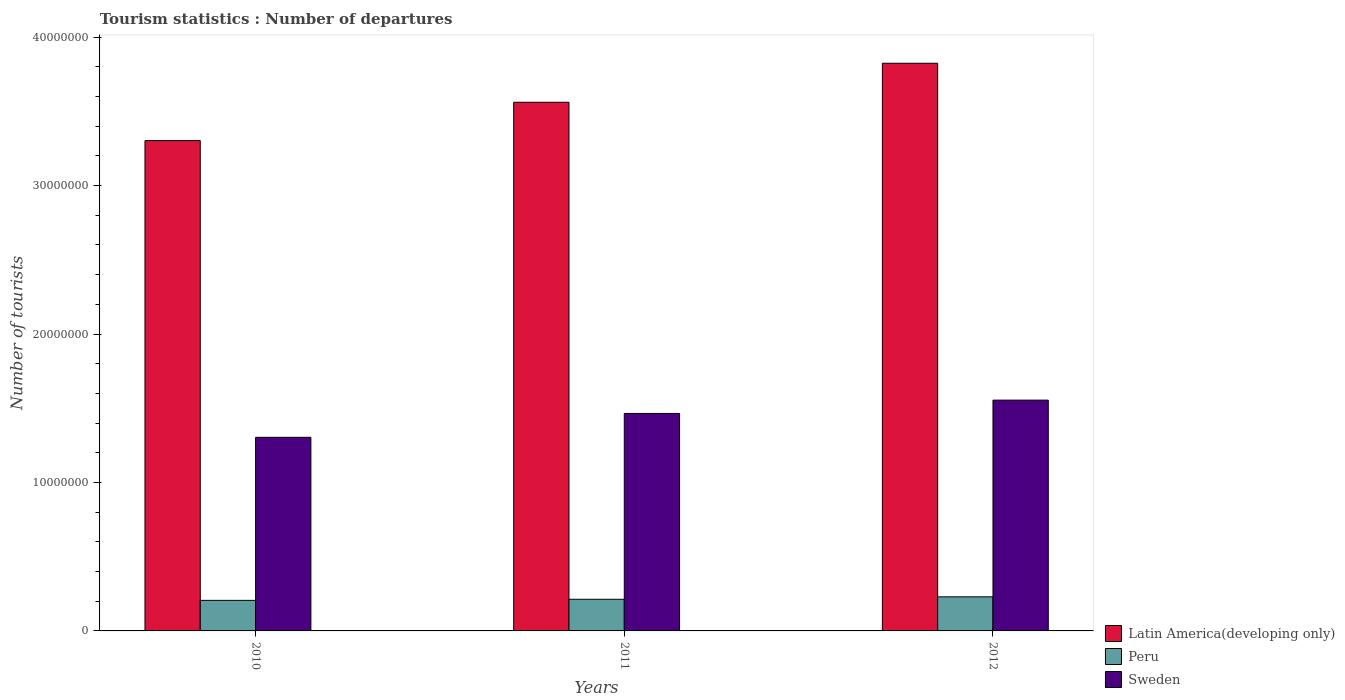How many groups of bars are there?
Keep it short and to the point. 3. Are the number of bars per tick equal to the number of legend labels?
Offer a terse response. Yes. Are the number of bars on each tick of the X-axis equal?
Keep it short and to the point. Yes. How many bars are there on the 3rd tick from the left?
Keep it short and to the point. 3. What is the label of the 1st group of bars from the left?
Your answer should be compact. 2010. In how many cases, is the number of bars for a given year not equal to the number of legend labels?
Ensure brevity in your answer.  0. What is the number of tourist departures in Latin America(developing only) in 2012?
Ensure brevity in your answer.  3.82e+07. Across all years, what is the maximum number of tourist departures in Sweden?
Provide a short and direct response. 1.55e+07. Across all years, what is the minimum number of tourist departures in Peru?
Offer a very short reply. 2.06e+06. What is the total number of tourist departures in Peru in the graph?
Make the answer very short. 6.49e+06. What is the difference between the number of tourist departures in Latin America(developing only) in 2011 and that in 2012?
Your response must be concise. -2.63e+06. What is the difference between the number of tourist departures in Sweden in 2010 and the number of tourist departures in Peru in 2012?
Keep it short and to the point. 1.07e+07. What is the average number of tourist departures in Sweden per year?
Your answer should be compact. 1.44e+07. In the year 2011, what is the difference between the number of tourist departures in Peru and number of tourist departures in Latin America(developing only)?
Provide a short and direct response. -3.35e+07. In how many years, is the number of tourist departures in Latin America(developing only) greater than 20000000?
Your answer should be compact. 3. What is the ratio of the number of tourist departures in Sweden in 2011 to that in 2012?
Your response must be concise. 0.94. Is the difference between the number of tourist departures in Peru in 2011 and 2012 greater than the difference between the number of tourist departures in Latin America(developing only) in 2011 and 2012?
Your answer should be compact. Yes. What is the difference between the highest and the second highest number of tourist departures in Sweden?
Provide a succinct answer. 8.97e+05. What is the difference between the highest and the lowest number of tourist departures in Latin America(developing only)?
Offer a terse response. 5.21e+06. Is the sum of the number of tourist departures in Sweden in 2010 and 2011 greater than the maximum number of tourist departures in Latin America(developing only) across all years?
Offer a terse response. No. What does the 1st bar from the left in 2010 represents?
Offer a very short reply. Latin America(developing only). How many years are there in the graph?
Your answer should be compact. 3. Are the values on the major ticks of Y-axis written in scientific E-notation?
Keep it short and to the point. No. Does the graph contain grids?
Keep it short and to the point. No. How many legend labels are there?
Offer a terse response. 3. How are the legend labels stacked?
Give a very brief answer. Vertical. What is the title of the graph?
Your response must be concise. Tourism statistics : Number of departures. What is the label or title of the Y-axis?
Ensure brevity in your answer.  Number of tourists. What is the Number of tourists of Latin America(developing only) in 2010?
Your answer should be very brief. 3.30e+07. What is the Number of tourists of Peru in 2010?
Your response must be concise. 2.06e+06. What is the Number of tourists of Sweden in 2010?
Your answer should be very brief. 1.30e+07. What is the Number of tourists in Latin America(developing only) in 2011?
Your response must be concise. 3.56e+07. What is the Number of tourists in Peru in 2011?
Keep it short and to the point. 2.13e+06. What is the Number of tourists of Sweden in 2011?
Offer a very short reply. 1.47e+07. What is the Number of tourists in Latin America(developing only) in 2012?
Your response must be concise. 3.82e+07. What is the Number of tourists in Peru in 2012?
Offer a very short reply. 2.30e+06. What is the Number of tourists in Sweden in 2012?
Provide a short and direct response. 1.55e+07. Across all years, what is the maximum Number of tourists in Latin America(developing only)?
Give a very brief answer. 3.82e+07. Across all years, what is the maximum Number of tourists in Peru?
Make the answer very short. 2.30e+06. Across all years, what is the maximum Number of tourists of Sweden?
Ensure brevity in your answer.  1.55e+07. Across all years, what is the minimum Number of tourists of Latin America(developing only)?
Your answer should be compact. 3.30e+07. Across all years, what is the minimum Number of tourists in Peru?
Give a very brief answer. 2.06e+06. Across all years, what is the minimum Number of tourists in Sweden?
Offer a terse response. 1.30e+07. What is the total Number of tourists of Latin America(developing only) in the graph?
Give a very brief answer. 1.07e+08. What is the total Number of tourists of Peru in the graph?
Ensure brevity in your answer.  6.49e+06. What is the total Number of tourists in Sweden in the graph?
Your answer should be very brief. 4.32e+07. What is the difference between the Number of tourists of Latin America(developing only) in 2010 and that in 2011?
Your answer should be very brief. -2.58e+06. What is the difference between the Number of tourists in Peru in 2010 and that in 2011?
Your answer should be very brief. -7.40e+04. What is the difference between the Number of tourists of Sweden in 2010 and that in 2011?
Provide a short and direct response. -1.61e+06. What is the difference between the Number of tourists of Latin America(developing only) in 2010 and that in 2012?
Give a very brief answer. -5.21e+06. What is the difference between the Number of tourists of Peru in 2010 and that in 2012?
Provide a short and direct response. -2.38e+05. What is the difference between the Number of tourists in Sweden in 2010 and that in 2012?
Offer a very short reply. -2.51e+06. What is the difference between the Number of tourists in Latin America(developing only) in 2011 and that in 2012?
Provide a succinct answer. -2.63e+06. What is the difference between the Number of tourists in Peru in 2011 and that in 2012?
Give a very brief answer. -1.64e+05. What is the difference between the Number of tourists of Sweden in 2011 and that in 2012?
Your answer should be very brief. -8.97e+05. What is the difference between the Number of tourists of Latin America(developing only) in 2010 and the Number of tourists of Peru in 2011?
Give a very brief answer. 3.09e+07. What is the difference between the Number of tourists of Latin America(developing only) in 2010 and the Number of tourists of Sweden in 2011?
Your answer should be very brief. 1.84e+07. What is the difference between the Number of tourists in Peru in 2010 and the Number of tourists in Sweden in 2011?
Your response must be concise. -1.26e+07. What is the difference between the Number of tourists in Latin America(developing only) in 2010 and the Number of tourists in Peru in 2012?
Give a very brief answer. 3.07e+07. What is the difference between the Number of tourists in Latin America(developing only) in 2010 and the Number of tourists in Sweden in 2012?
Provide a succinct answer. 1.75e+07. What is the difference between the Number of tourists of Peru in 2010 and the Number of tourists of Sweden in 2012?
Provide a succinct answer. -1.35e+07. What is the difference between the Number of tourists of Latin America(developing only) in 2011 and the Number of tourists of Peru in 2012?
Ensure brevity in your answer.  3.33e+07. What is the difference between the Number of tourists of Latin America(developing only) in 2011 and the Number of tourists of Sweden in 2012?
Ensure brevity in your answer.  2.01e+07. What is the difference between the Number of tourists in Peru in 2011 and the Number of tourists in Sweden in 2012?
Keep it short and to the point. -1.34e+07. What is the average Number of tourists of Latin America(developing only) per year?
Provide a succinct answer. 3.56e+07. What is the average Number of tourists of Peru per year?
Make the answer very short. 2.16e+06. What is the average Number of tourists in Sweden per year?
Provide a short and direct response. 1.44e+07. In the year 2010, what is the difference between the Number of tourists in Latin America(developing only) and Number of tourists in Peru?
Offer a very short reply. 3.10e+07. In the year 2010, what is the difference between the Number of tourists of Latin America(developing only) and Number of tourists of Sweden?
Offer a very short reply. 2.00e+07. In the year 2010, what is the difference between the Number of tourists in Peru and Number of tourists in Sweden?
Your answer should be compact. -1.10e+07. In the year 2011, what is the difference between the Number of tourists in Latin America(developing only) and Number of tourists in Peru?
Your answer should be compact. 3.35e+07. In the year 2011, what is the difference between the Number of tourists of Latin America(developing only) and Number of tourists of Sweden?
Offer a very short reply. 2.10e+07. In the year 2011, what is the difference between the Number of tourists in Peru and Number of tourists in Sweden?
Make the answer very short. -1.25e+07. In the year 2012, what is the difference between the Number of tourists of Latin America(developing only) and Number of tourists of Peru?
Your response must be concise. 3.59e+07. In the year 2012, what is the difference between the Number of tourists in Latin America(developing only) and Number of tourists in Sweden?
Provide a short and direct response. 2.27e+07. In the year 2012, what is the difference between the Number of tourists in Peru and Number of tourists in Sweden?
Ensure brevity in your answer.  -1.33e+07. What is the ratio of the Number of tourists of Latin America(developing only) in 2010 to that in 2011?
Provide a short and direct response. 0.93. What is the ratio of the Number of tourists of Peru in 2010 to that in 2011?
Make the answer very short. 0.97. What is the ratio of the Number of tourists in Sweden in 2010 to that in 2011?
Provide a succinct answer. 0.89. What is the ratio of the Number of tourists of Latin America(developing only) in 2010 to that in 2012?
Give a very brief answer. 0.86. What is the ratio of the Number of tourists of Peru in 2010 to that in 2012?
Your answer should be compact. 0.9. What is the ratio of the Number of tourists in Sweden in 2010 to that in 2012?
Give a very brief answer. 0.84. What is the ratio of the Number of tourists of Latin America(developing only) in 2011 to that in 2012?
Provide a short and direct response. 0.93. What is the ratio of the Number of tourists in Sweden in 2011 to that in 2012?
Your answer should be compact. 0.94. What is the difference between the highest and the second highest Number of tourists in Latin America(developing only)?
Provide a succinct answer. 2.63e+06. What is the difference between the highest and the second highest Number of tourists of Peru?
Your answer should be compact. 1.64e+05. What is the difference between the highest and the second highest Number of tourists of Sweden?
Make the answer very short. 8.97e+05. What is the difference between the highest and the lowest Number of tourists in Latin America(developing only)?
Offer a terse response. 5.21e+06. What is the difference between the highest and the lowest Number of tourists in Peru?
Keep it short and to the point. 2.38e+05. What is the difference between the highest and the lowest Number of tourists in Sweden?
Your response must be concise. 2.51e+06. 